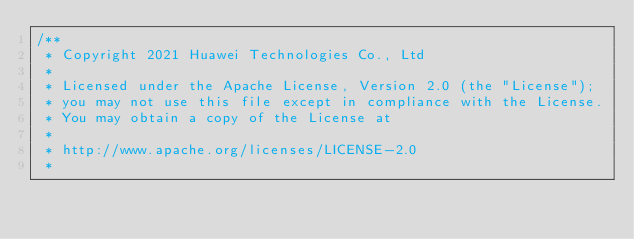Convert code to text. <code><loc_0><loc_0><loc_500><loc_500><_C++_>/**
 * Copyright 2021 Huawei Technologies Co., Ltd
 *
 * Licensed under the Apache License, Version 2.0 (the "License");
 * you may not use this file except in compliance with the License.
 * You may obtain a copy of the License at
 *
 * http://www.apache.org/licenses/LICENSE-2.0
 *</code> 